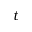<formula> <loc_0><loc_0><loc_500><loc_500>t</formula> 